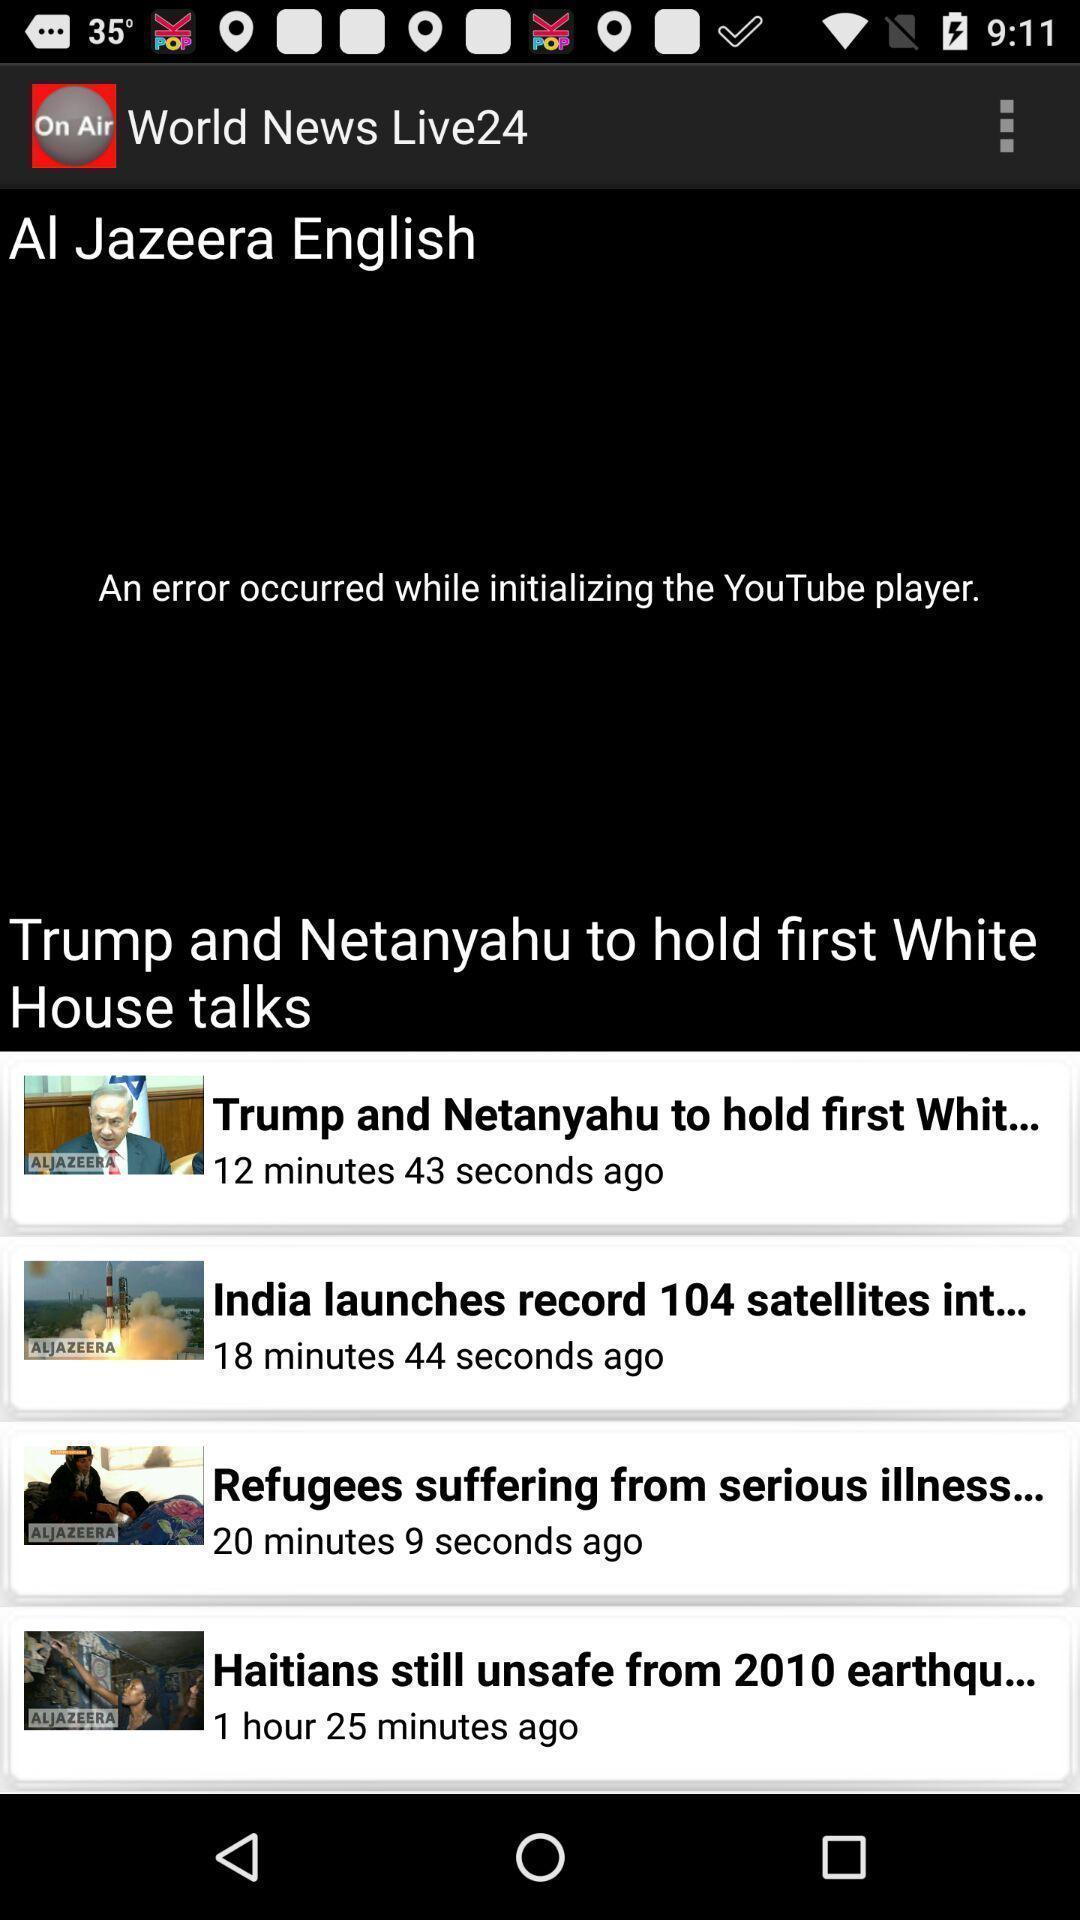Give me a narrative description of this picture. Screen showing various news updates in a news app. 